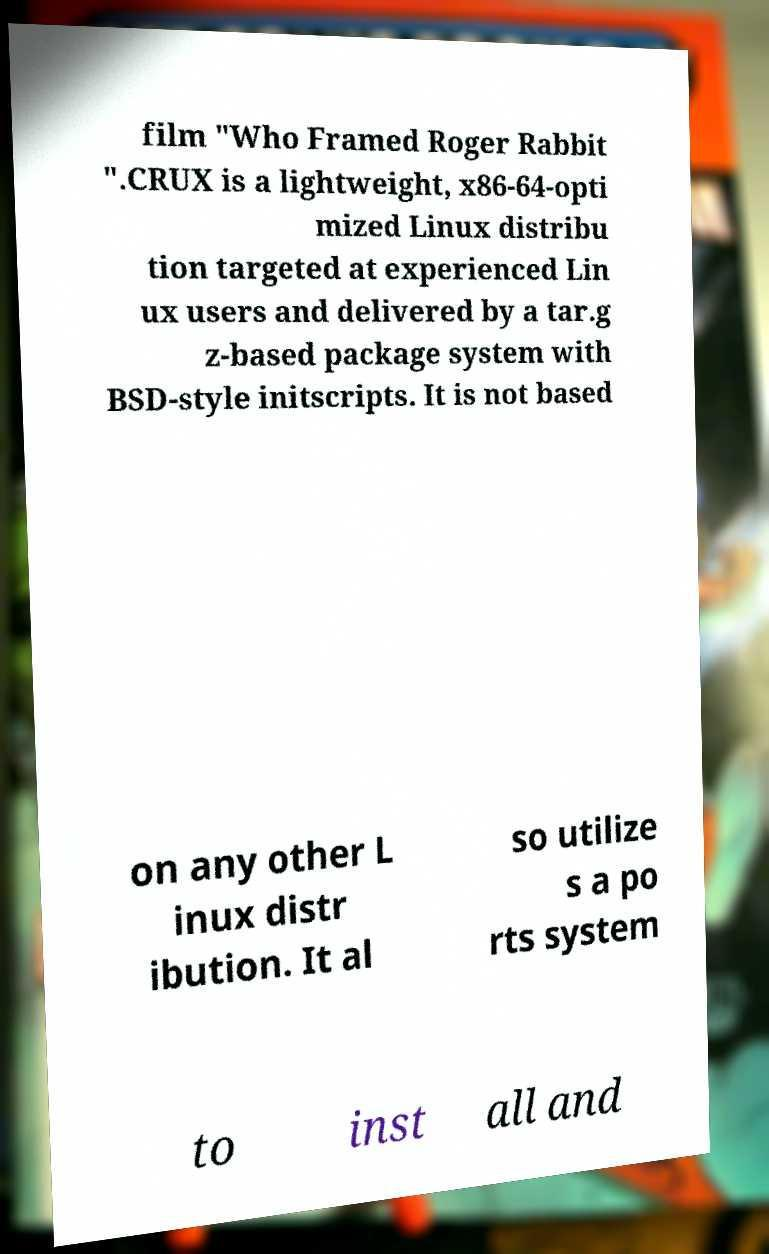Could you assist in decoding the text presented in this image and type it out clearly? film "Who Framed Roger Rabbit ".CRUX is a lightweight, x86-64-opti mized Linux distribu tion targeted at experienced Lin ux users and delivered by a tar.g z-based package system with BSD-style initscripts. It is not based on any other L inux distr ibution. It al so utilize s a po rts system to inst all and 